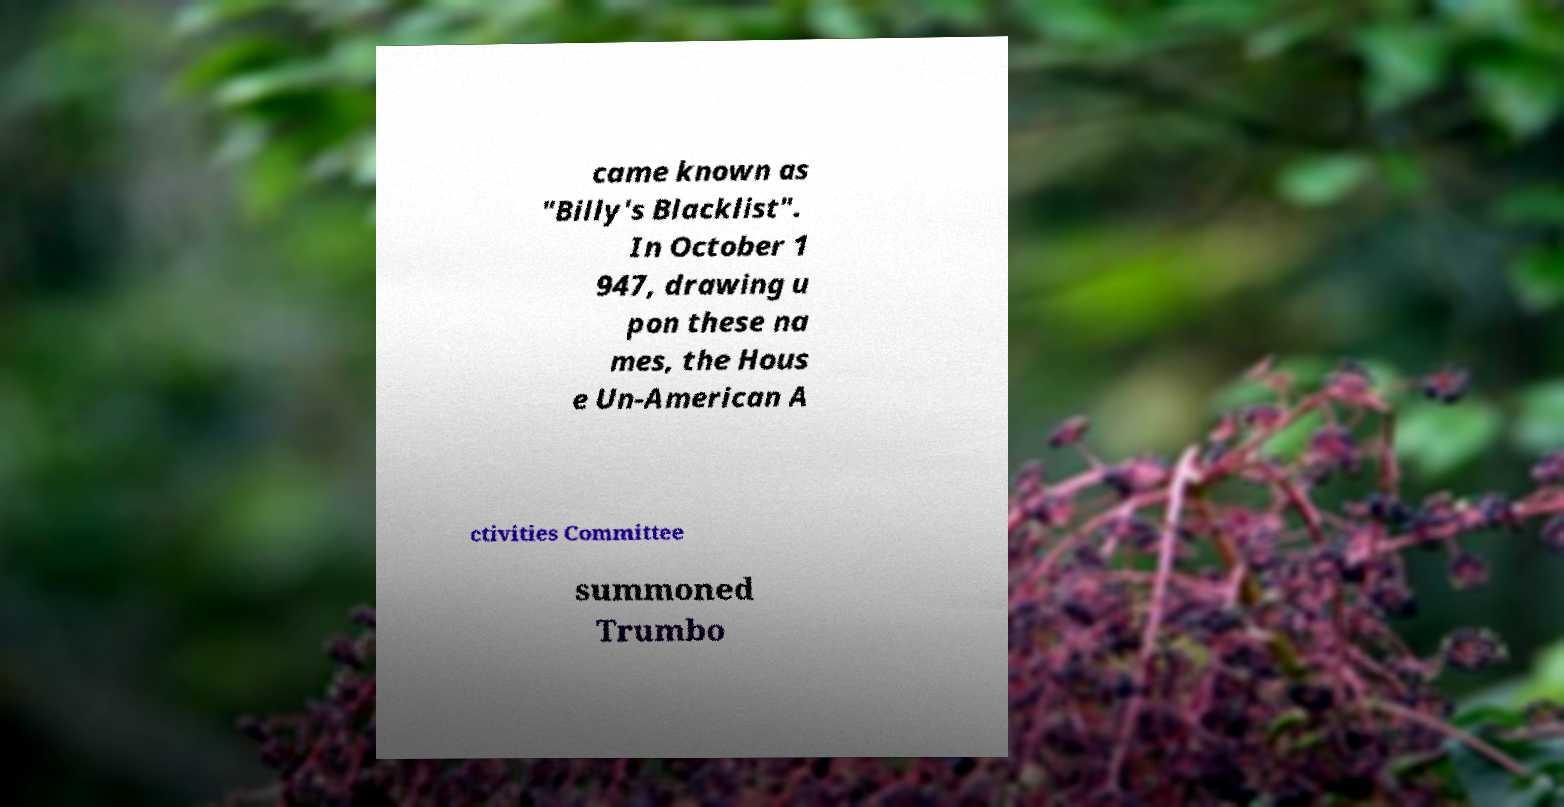What messages or text are displayed in this image? I need them in a readable, typed format. came known as "Billy's Blacklist". In October 1 947, drawing u pon these na mes, the Hous e Un-American A ctivities Committee summoned Trumbo 